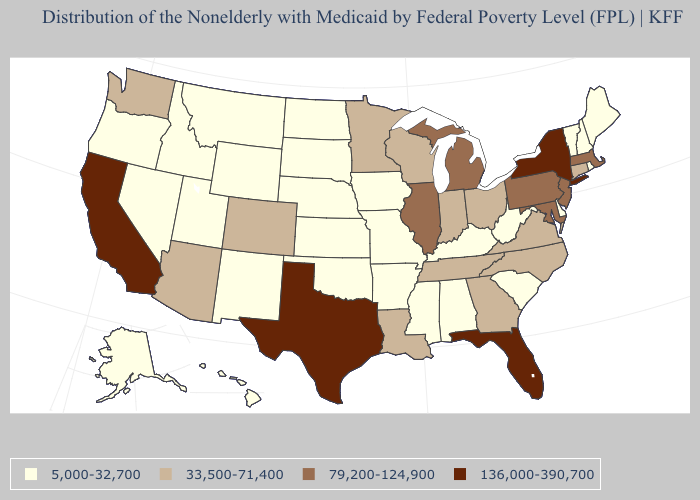Does Vermont have the lowest value in the USA?
Answer briefly. Yes. Among the states that border Kansas , which have the highest value?
Concise answer only. Colorado. What is the value of North Dakota?
Be succinct. 5,000-32,700. What is the value of Connecticut?
Short answer required. 33,500-71,400. Among the states that border Arkansas , does Tennessee have the lowest value?
Keep it brief. No. Does Hawaii have the same value as Virginia?
Write a very short answer. No. Does the map have missing data?
Quick response, please. No. What is the value of South Carolina?
Short answer required. 5,000-32,700. Does South Carolina have the highest value in the USA?
Answer briefly. No. What is the value of North Dakota?
Write a very short answer. 5,000-32,700. What is the highest value in the USA?
Quick response, please. 136,000-390,700. Which states have the lowest value in the South?
Quick response, please. Alabama, Arkansas, Delaware, Kentucky, Mississippi, Oklahoma, South Carolina, West Virginia. Name the states that have a value in the range 33,500-71,400?
Quick response, please. Arizona, Colorado, Connecticut, Georgia, Indiana, Louisiana, Minnesota, North Carolina, Ohio, Tennessee, Virginia, Washington, Wisconsin. Name the states that have a value in the range 33,500-71,400?
Give a very brief answer. Arizona, Colorado, Connecticut, Georgia, Indiana, Louisiana, Minnesota, North Carolina, Ohio, Tennessee, Virginia, Washington, Wisconsin. What is the value of Tennessee?
Write a very short answer. 33,500-71,400. 